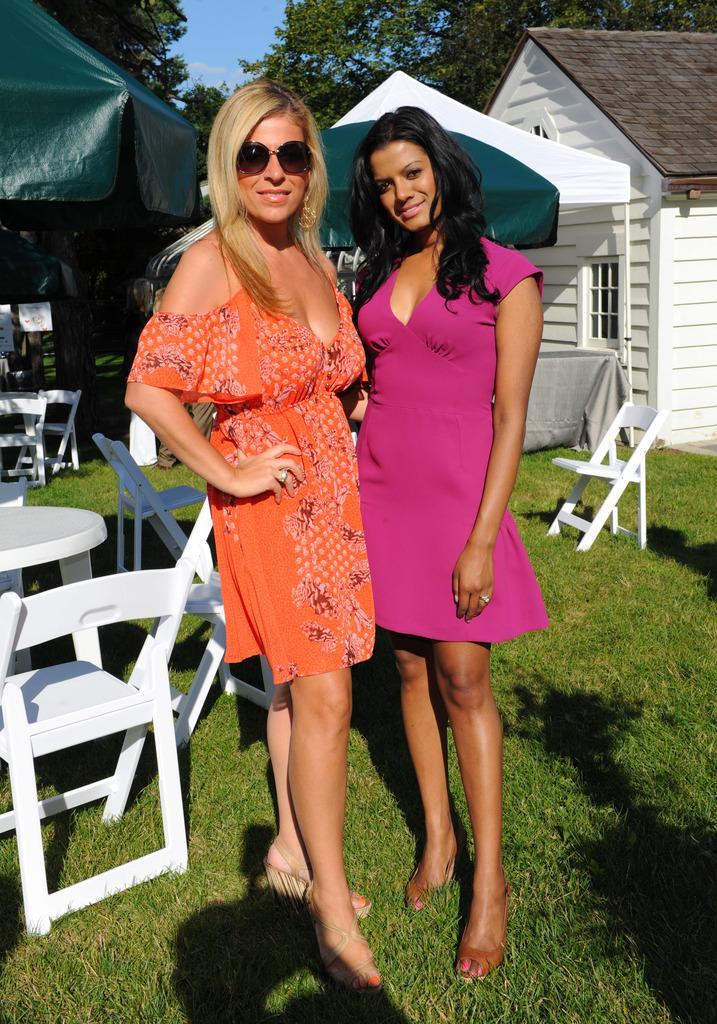In one or two sentences, can you explain what this image depicts? In the center of the image we can see the two ladies are standing. In the background of the image we can see the chairs, tables, tents, house, door, wall, roof and trees. At the bottom of the image we can see the ground. At the top of the image we can see the clouds are present in the sky. 